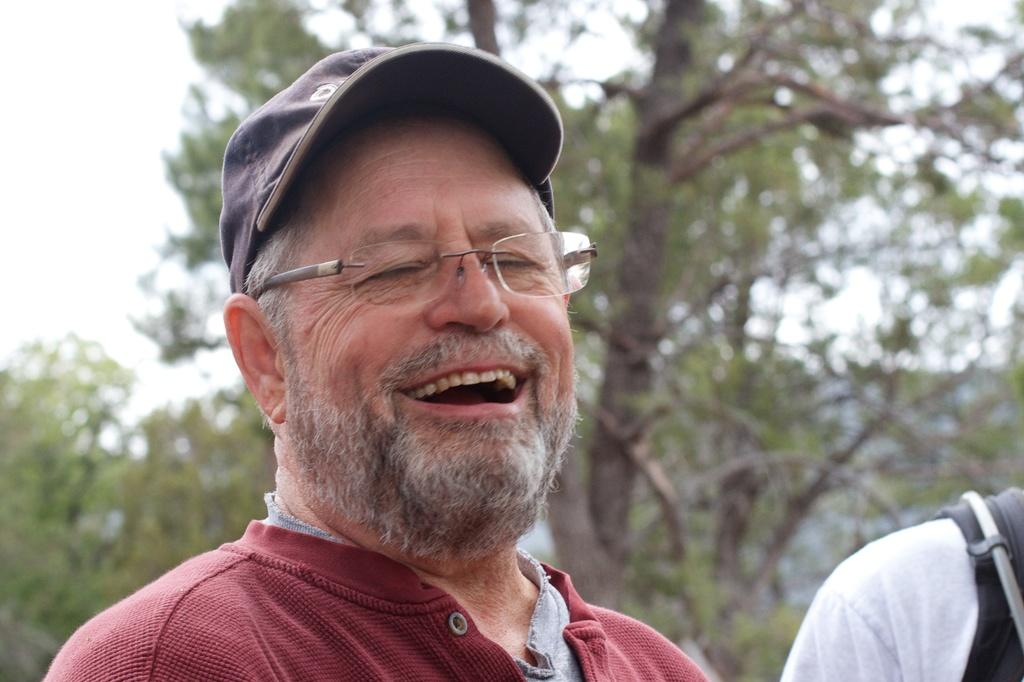Who is the main subject in the image? There is a man in the image. What is the man wearing? The man is wearing a red T-shirt. What is the man doing in the image? The man is laughing. Can you describe the other person in the image? There is another person in the image, but no specific details are provided. What can be seen in the background of the image? There are trees in the background of the image. What is visible at the top of the image? The sky is visible at the top of the image. How many kitties are holding the man's hands in the image? There are no kitties present in the image, and the man's hands are not visible. 